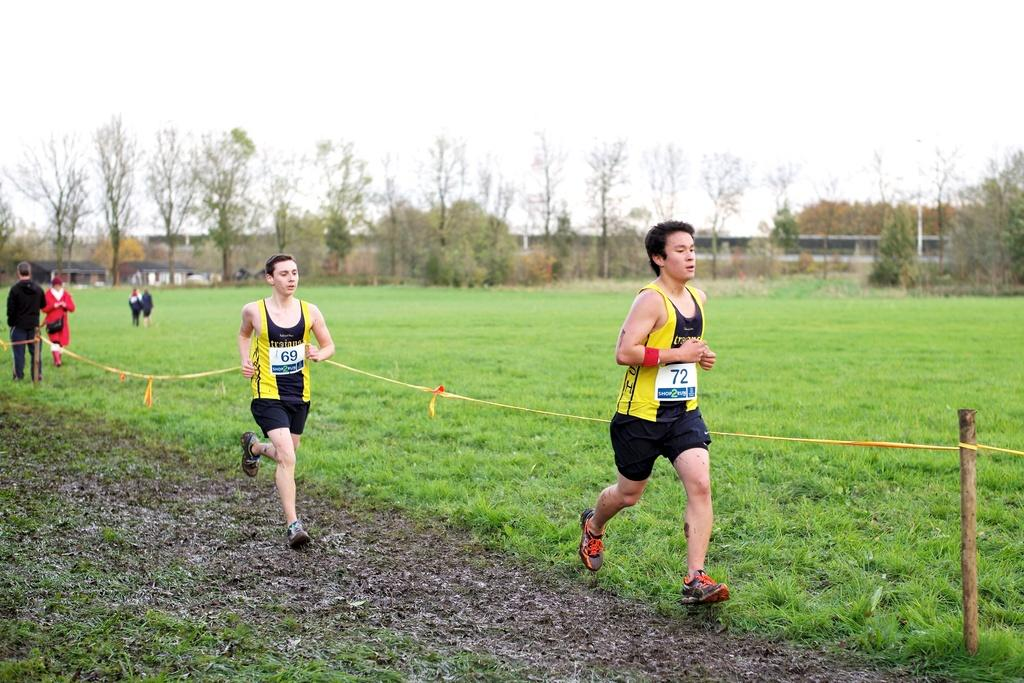Provide a one-sentence caption for the provided image. In a foot race over muddy ground, contestant 72 is ahead of 69. 